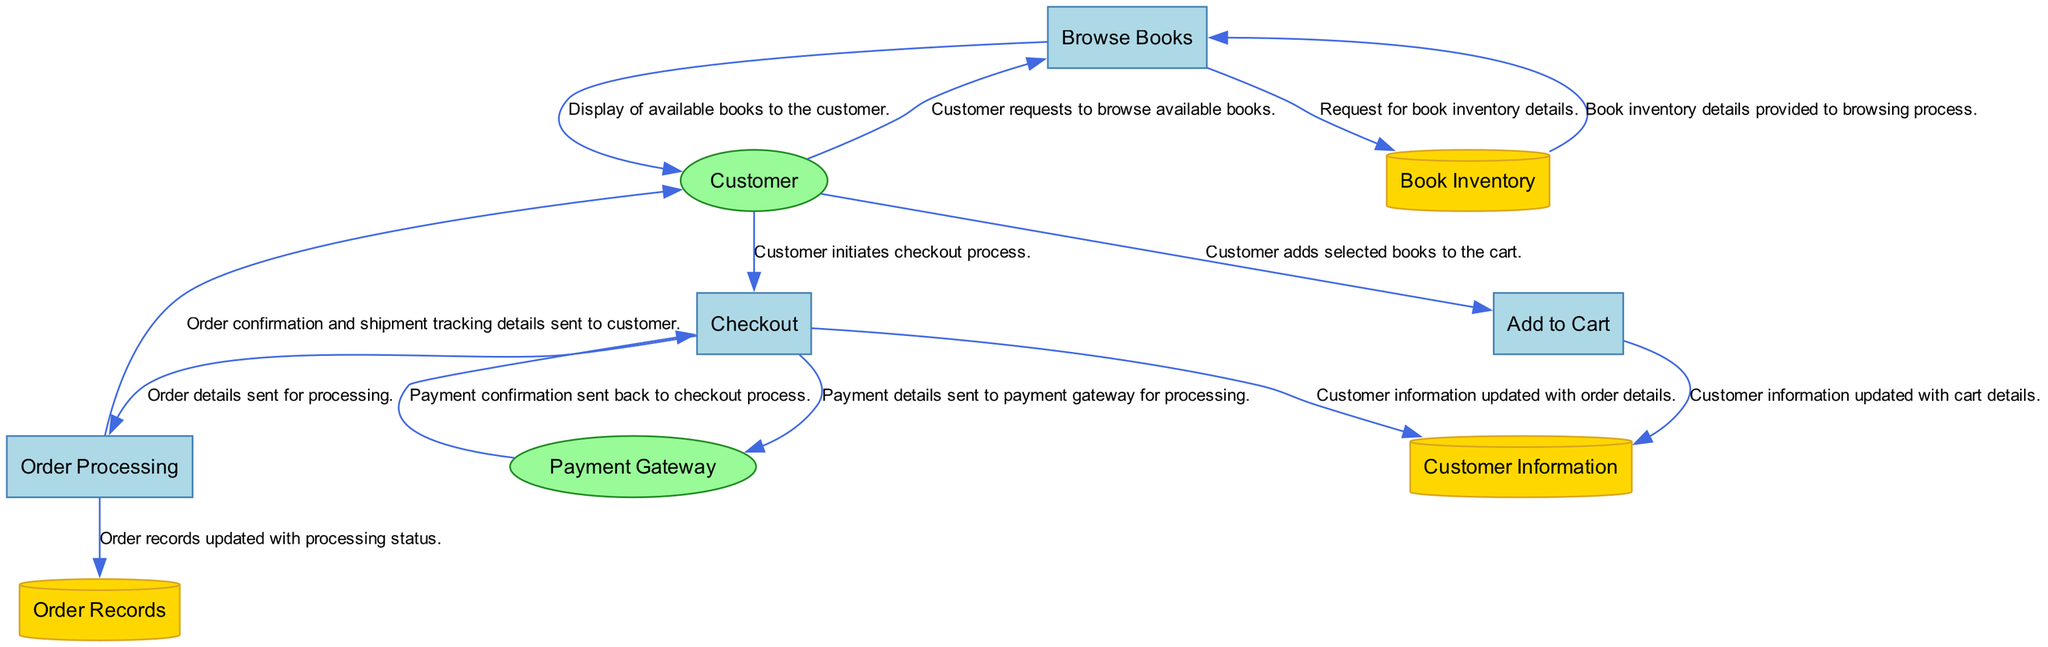What is the first process in the diagram? The first process is labeled as "P1", which corresponds to "Browse Books". It is the initial step in the online bookstore purchase process as indicated in the diagram.
Answer: Browse Books How many data stores are present in the diagram? The diagram lists three data stores: Book Inventory, Customer Information, and Order Records. The count of these data stores provides the answer.
Answer: Three Which entity is responsible for processing payments? The entity labeled as "E2" refers to the Payment Gateway, which is the designated third-party service that processes customer payments securely.
Answer: Payment Gateway What is the last process in the purchase flow? The last process is labeled as "P4", which corresponds to "Order Processing". This indicates the final step in handling the order after payment has been confirmed.
Answer: Order Processing How many processes are involved in the online bookstore purchase process? The diagram indicates a total of four processes: Browse Books, Add to Cart, Checkout, and Order Processing. By counting them, you can determine the total number of processes involved.
Answer: Four What data flow occurs after the customer initiates the checkout process? After the customer initiates the checkout process (P3), the next data flow involves sending payment details to the Payment Gateway (E2) for processing. This is a crucial step to ensure the transaction is completed.
Answer: Payment details sent to payment gateway What updates occur in the Customer Information data store (D2)? The Customer Information data store is updated twice during the processes: once with cart details after adding to the cart (P2), and once with order details after the checkout process (P3). This indicates that customer data is tracked throughout the purchasing stages.
Answer: Updated with cart and order details What does the Order Processing process send to the customer? The Order Processing process sends an order confirmation and shipment tracking details to the customer (E1). This communication is essential for providing the customer with the status and tracking of their order.
Answer: Order confirmation and tracking details Which data store is updated with the order records? The data store labeled as "D3" is where the order records are updated with processing status. It indicates that this is the storage for historical data regarding orders placed by customers.
Answer: Order Records 